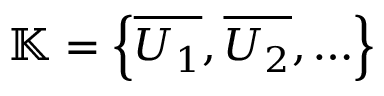Convert formula to latex. <formula><loc_0><loc_0><loc_500><loc_500>\mathbb { K } = \left \{ { \overline { { U _ { 1 } } } } , { \overline { { U _ { 2 } } } } , \dots \right \}</formula> 